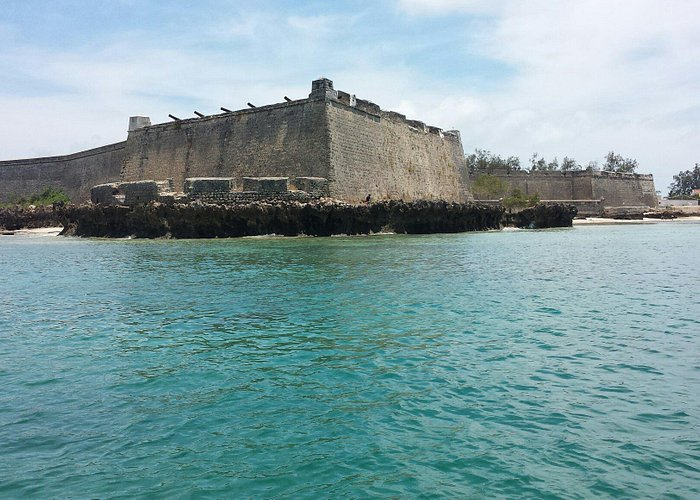What stands out to you about the architecture of this fort? The architecture of the Fort of São Sebastião stands out due to its imposing stone structure, rectangular shape, and flat roof. The design is indicative of military architecture meant to withstand sieges and provide a strong defense. However, what adds to its charm are the signs of aging—crumbling walls and missing roof parts—that narrate stories of its historical endurance. Can you delve deeper into the historical significance of this fort? Absolutely. The Fort of São Sebastião, completed in 1558, is one of the oldest European buildings in the Southern Hemisphere. It played a crucial role during the Portuguese colonial era, serving as a strategic defensive stronghold against maritime threats. Over the centuries, it has witnessed numerous historical events, including battles for control of the region. Despite the wear and tear seen today, its presence is a testament to the resilience and historical evolution of Mozambique Island. Imagine if the fort could speak; what stories might it tell? If the fort could speak, it would share tales of the bustling activity within its walls during the height of Portuguese colonialism, the strategic military planning sessions, the sound of cannons during defending battles, and the whispers of soldiers and administrators who lived and worked there. It might recount the silent nights under starry skies, the ocean’s relentless waves immortalizing countless dawns and dusk. The fort would tell of its transformation over the centuries, standing as a silent witness to the passing of time and the changing tides of power and culture. What might this fort have looked like in its prime? In its prime, the Fort of São Sebastião would have been a formidable and imposing structure, its walls freshly hewn from solid stone, standing tall and unblemished. The roof would be intact, the battlements strong and unyielding, with watchtowers providing panoramic views of the surrounding ocean and land. Vibrant banners might have flown in the breeze, signaling its allegiance. Inside, the fort would bustle with activity, soldiers training, strategists plotting, and tradesmen supplying the needs of the fort's occupants. The sea surrounding it would be filled with ships coming and going, and the fort would stand as a symbol of strength and control in the region. 